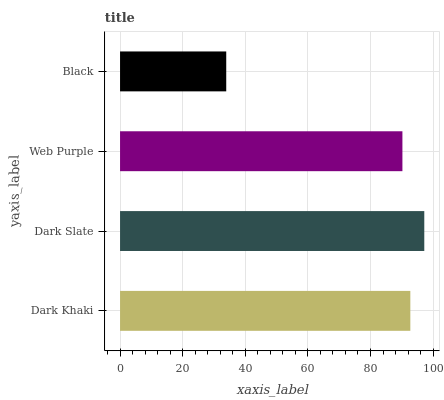Is Black the minimum?
Answer yes or no. Yes. Is Dark Slate the maximum?
Answer yes or no. Yes. Is Web Purple the minimum?
Answer yes or no. No. Is Web Purple the maximum?
Answer yes or no. No. Is Dark Slate greater than Web Purple?
Answer yes or no. Yes. Is Web Purple less than Dark Slate?
Answer yes or no. Yes. Is Web Purple greater than Dark Slate?
Answer yes or no. No. Is Dark Slate less than Web Purple?
Answer yes or no. No. Is Dark Khaki the high median?
Answer yes or no. Yes. Is Web Purple the low median?
Answer yes or no. Yes. Is Web Purple the high median?
Answer yes or no. No. Is Black the low median?
Answer yes or no. No. 